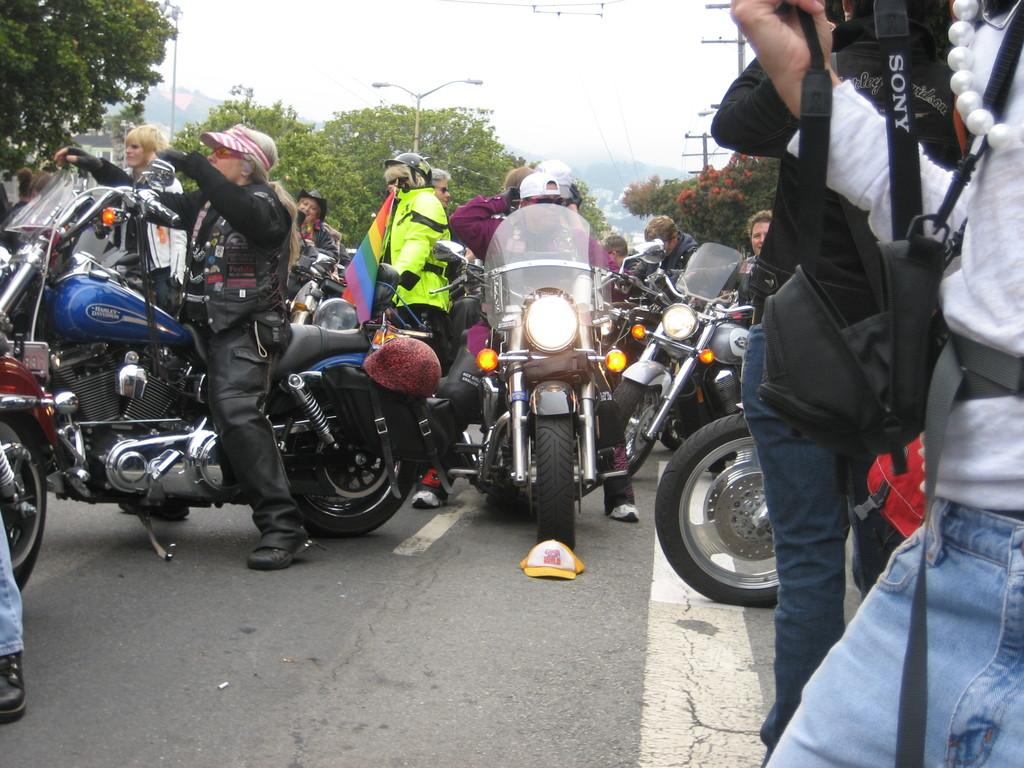Who is the person in the image? There is a man in the image. What is the man doing in the image? The man is sitting on a bike. What is present on the road in the image? There is a cap on the road in the image. What type of vegetation can be seen in the image? There are trees visible at the back side of the image. How many toes are visible on the man's feet in the image? The image does not show the man's feet, so the number of toes cannot be determined. 